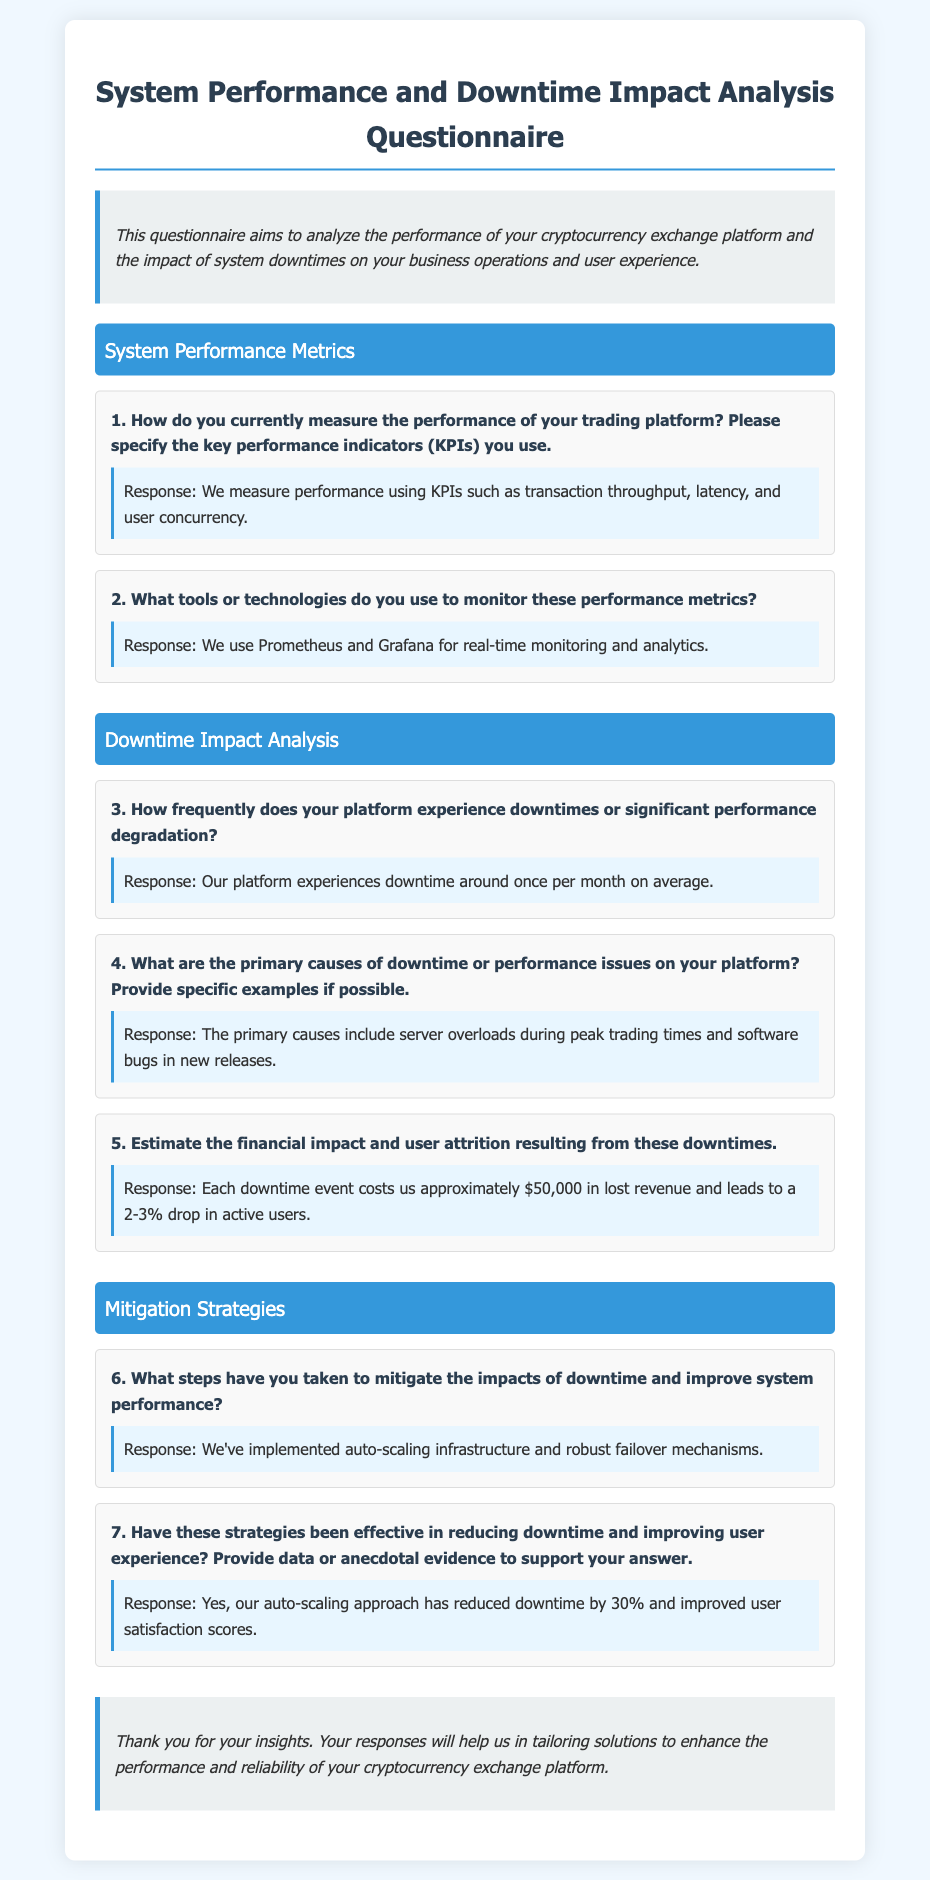what are the key performance indicators used to measure performance? The KPIs used to measure performance are mentioned in the first question under System Performance Metrics.
Answer: transaction throughput, latency, and user concurrency what tools are used for monitoring performance metrics? The tools used for monitoring are specified in the second question of the System Performance Metrics section.
Answer: Prometheus and Grafana how often does the platform experience downtime? The frequency of downtime is provided in the third question under Downtime Impact Analysis.
Answer: once per month what is the estimated financial impact of downtime? The financial impact estimate can be found in the fifth question of the Downtime Impact Analysis section.
Answer: $50,000 what improvements have been made to reduce downtime? The steps taken to mitigate impacts of downtime are explained in the sixth question under Mitigation Strategies.
Answer: auto-scaling infrastructure and robust failover mechanisms how much has downtime been reduced by the new strategies? The effectiveness of strategies on downtime reduction is stated in the seventh question under Mitigation Strategies.
Answer: 30% 